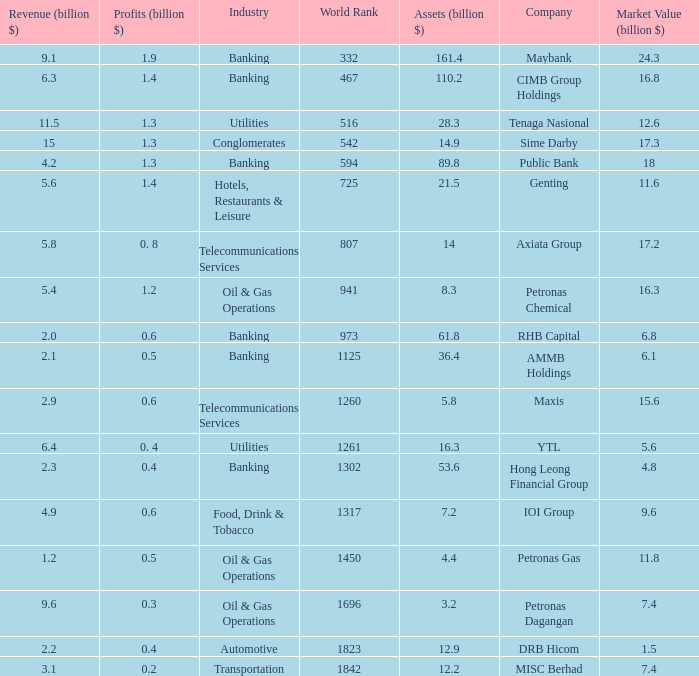Name the industry for revenue being 2.1 Banking. 